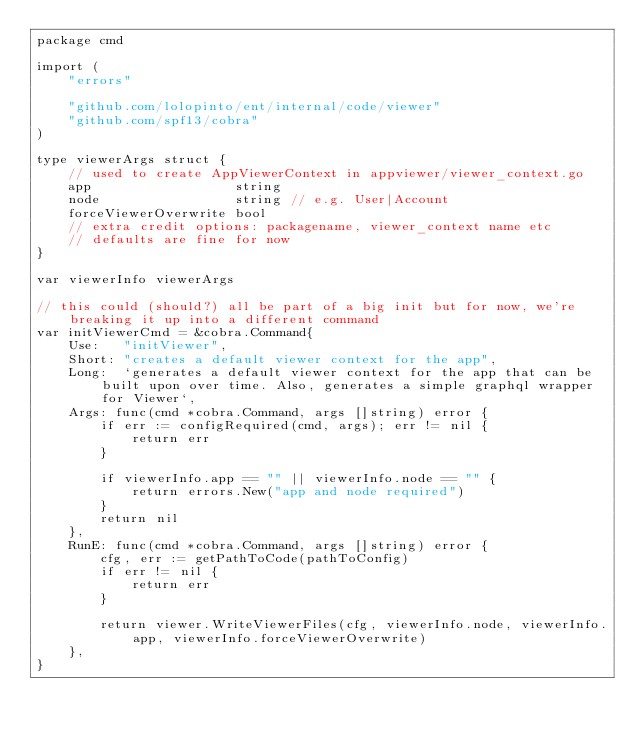Convert code to text. <code><loc_0><loc_0><loc_500><loc_500><_Go_>package cmd

import (
	"errors"

	"github.com/lolopinto/ent/internal/code/viewer"
	"github.com/spf13/cobra"
)

type viewerArgs struct {
	// used to create AppViewerContext in appviewer/viewer_context.go
	app                  string
	node                 string // e.g. User|Account
	forceViewerOverwrite bool
	// extra credit options: packagename, viewer_context name etc
	// defaults are fine for now
}

var viewerInfo viewerArgs

// this could (should?) all be part of a big init but for now, we're breaking it up into a different command
var initViewerCmd = &cobra.Command{
	Use:   "initViewer",
	Short: "creates a default viewer context for the app",
	Long:  `generates a default viewer context for the app that can be built upon over time. Also, generates a simple graphql wrapper for Viewer`,
	Args: func(cmd *cobra.Command, args []string) error {
		if err := configRequired(cmd, args); err != nil {
			return err
		}

		if viewerInfo.app == "" || viewerInfo.node == "" {
			return errors.New("app and node required")
		}
		return nil
	},
	RunE: func(cmd *cobra.Command, args []string) error {
		cfg, err := getPathToCode(pathToConfig)
		if err != nil {
			return err
		}

		return viewer.WriteViewerFiles(cfg, viewerInfo.node, viewerInfo.app, viewerInfo.forceViewerOverwrite)
	},
}
</code> 